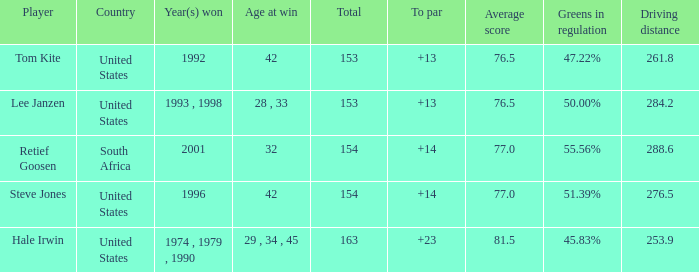What is the highest to par that is less than 153 None. 